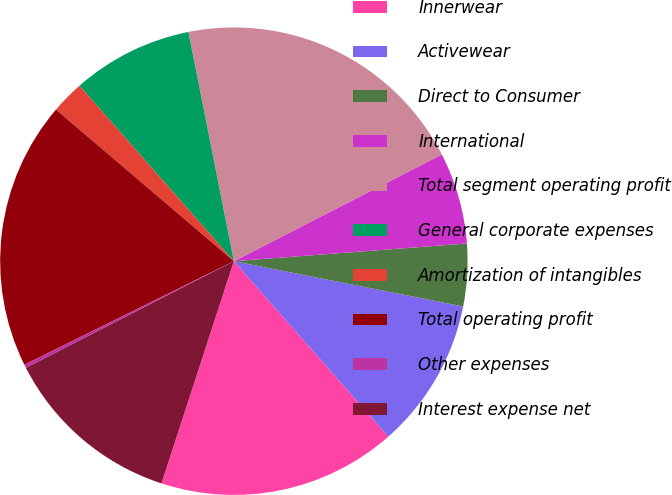Convert chart to OTSL. <chart><loc_0><loc_0><loc_500><loc_500><pie_chart><fcel>Innerwear<fcel>Activewear<fcel>Direct to Consumer<fcel>International<fcel>Total segment operating profit<fcel>General corporate expenses<fcel>Amortization of intangibles<fcel>Total operating profit<fcel>Other expenses<fcel>Interest expense net<nl><fcel>16.5%<fcel>10.41%<fcel>4.31%<fcel>6.34%<fcel>20.57%<fcel>8.37%<fcel>2.28%<fcel>18.54%<fcel>0.24%<fcel>12.44%<nl></chart> 